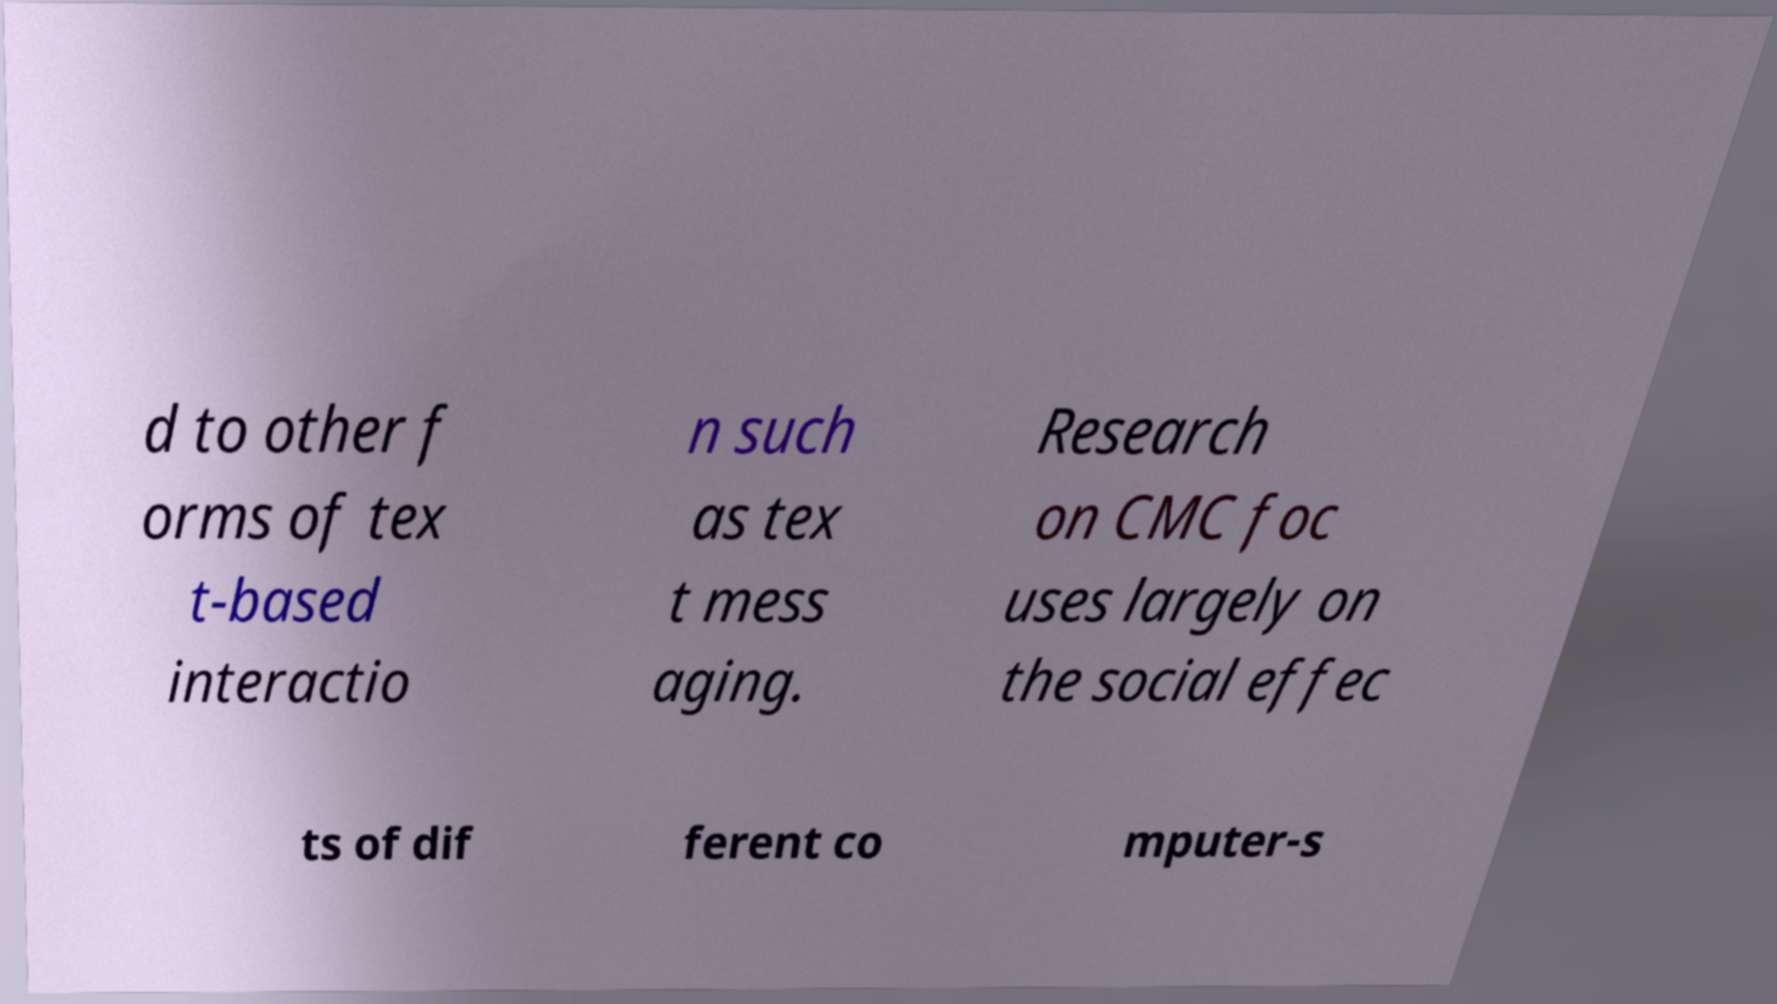For documentation purposes, I need the text within this image transcribed. Could you provide that? d to other f orms of tex t-based interactio n such as tex t mess aging. Research on CMC foc uses largely on the social effec ts of dif ferent co mputer-s 